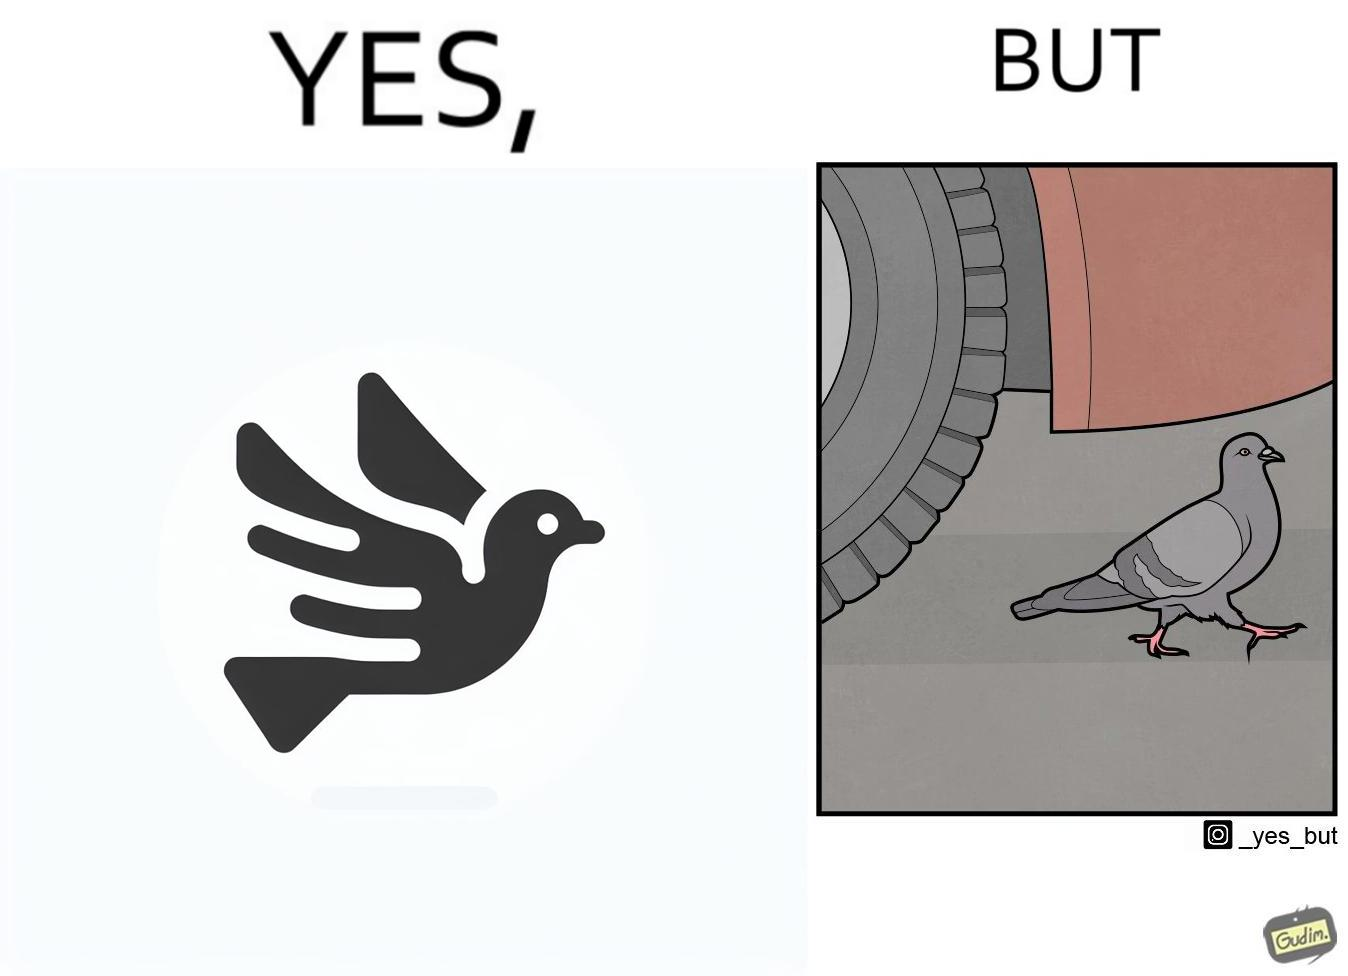Describe what you see in this image. The image is ironic, because even when the pigeon has wings to fly it is walking even when it seems threatening to its life 